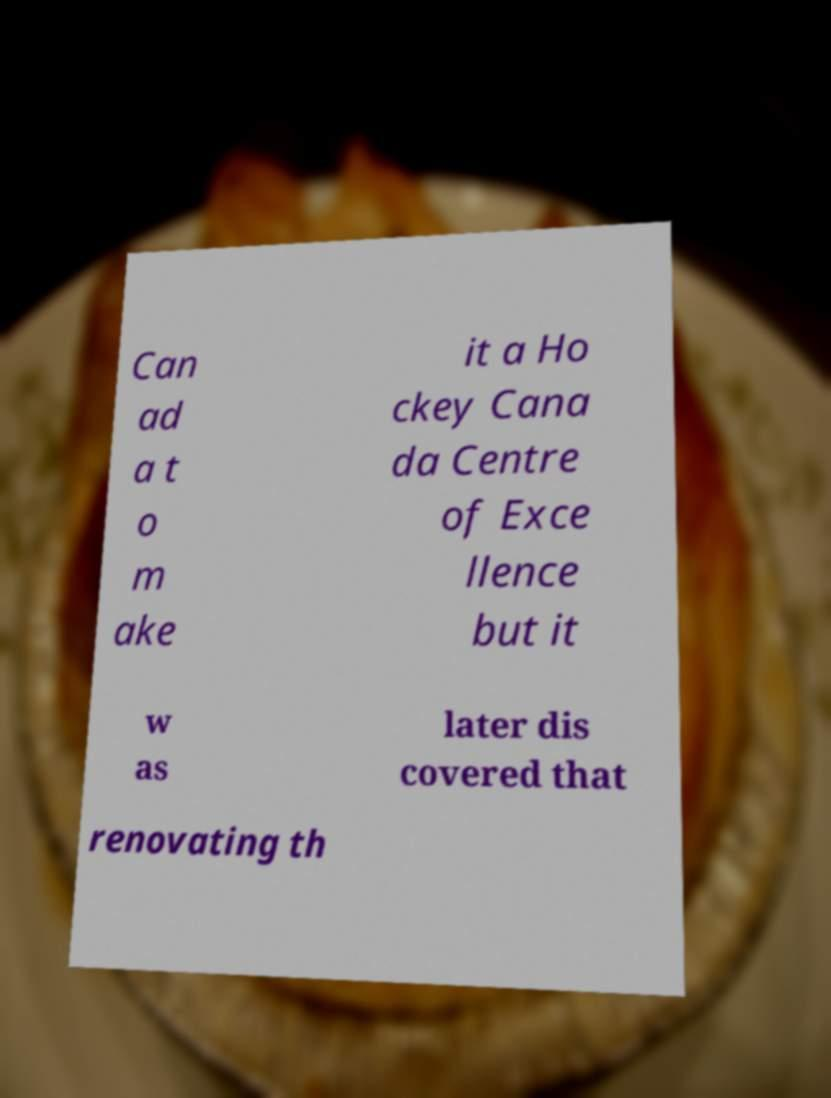Can you read and provide the text displayed in the image?This photo seems to have some interesting text. Can you extract and type it out for me? Can ad a t o m ake it a Ho ckey Cana da Centre of Exce llence but it w as later dis covered that renovating th 